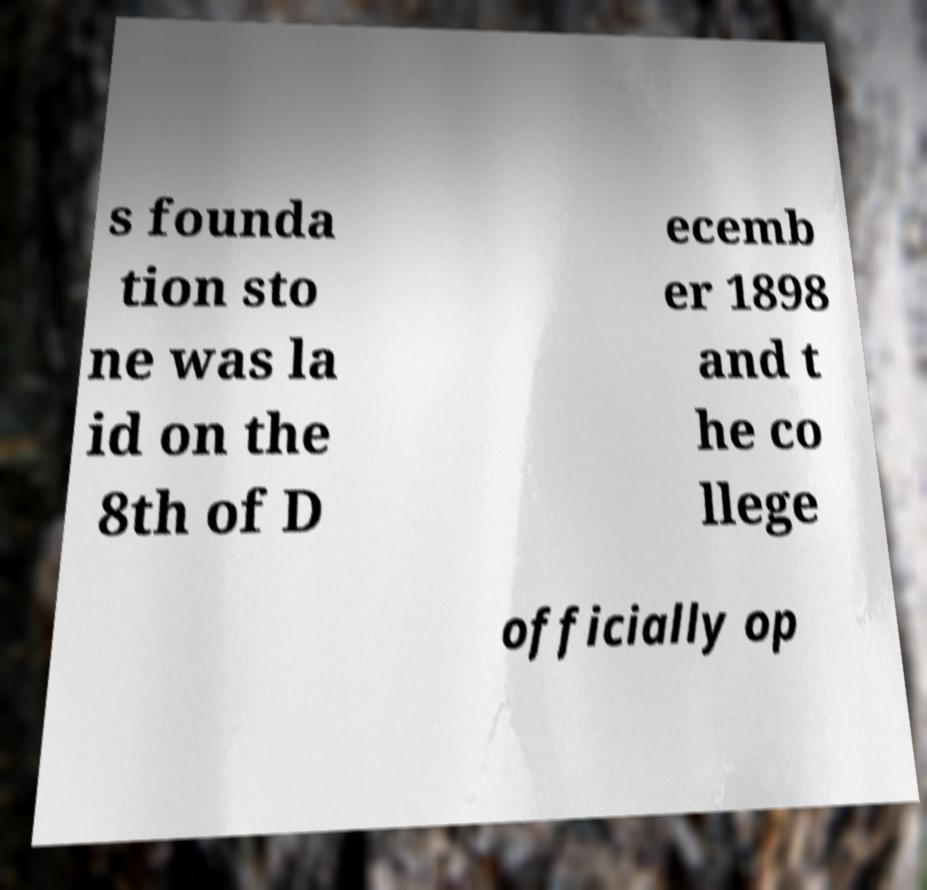What messages or text are displayed in this image? I need them in a readable, typed format. s founda tion sto ne was la id on the 8th of D ecemb er 1898 and t he co llege officially op 